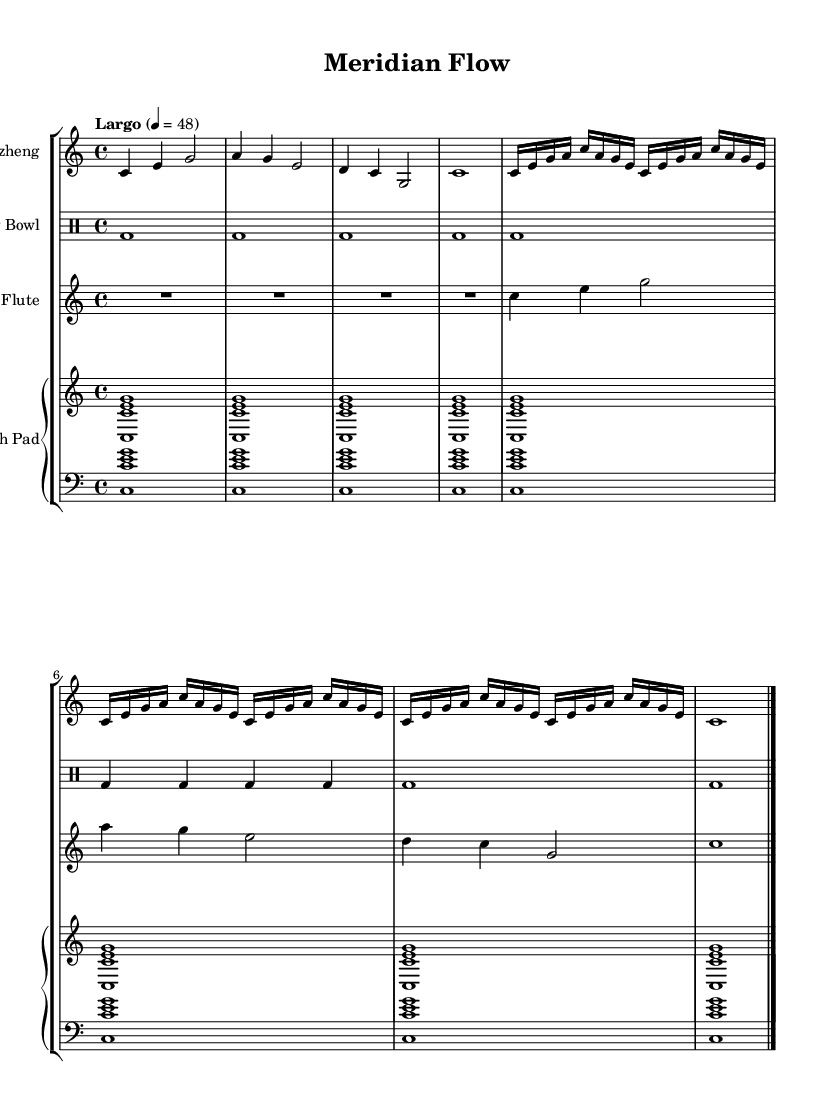What is the key signature of this music? The key signature is C major, which has no sharps or flats indicated at the beginning of the staff.
Answer: C major What is the time signature of the piece? The time signature is noted as 4/4, which indicates there are four beats in each measure and the quarter note receives one beat.
Answer: 4/4 What is the tempo marking for this composition? The tempo marking is written as "Largo," indicating a slow tempo, specifically 48 beats per minute.
Answer: Largo How many times does the guzheng part repeat its sequence? The guzheng part has a repeat sign for the section of notes between the first and second double barlines, which suggests that this section is played three times.
Answer: 3 What is the instrument used for the rhythmic foundation? The rhythmic foundation is primarily created using the singing bowl, indicated by the drum staff that displays only bass drum hits.
Answer: Singing bowl How many distinct instruments are featured in this score? The score includes four distinct instruments: Guzheng, Singing Bowl, Bamboo Flute, and Synth Pad, reflected in the separate staves for each.
Answer: Four 